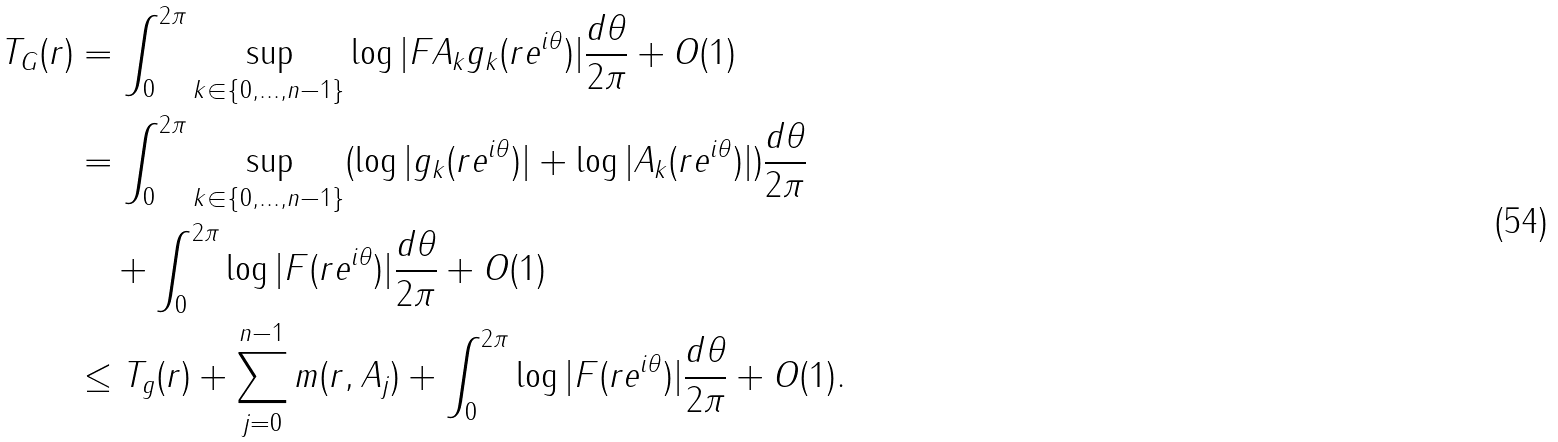Convert formula to latex. <formula><loc_0><loc_0><loc_500><loc_500>T _ { G } ( r ) & = \int _ { 0 } ^ { 2 \pi } \sup _ { k \in \{ 0 , \dots , n - 1 \} } \log | F A _ { k } g _ { k } ( r e ^ { i \theta } ) | \frac { d \theta } { 2 \pi } + O ( 1 ) \\ & = \int _ { 0 } ^ { 2 \pi } \sup _ { k \in \{ 0 , \dots , n - 1 \} } ( \log | g _ { k } ( r e ^ { i \theta } ) | + \log | A _ { k } ( r e ^ { i \theta } ) | ) \frac { d \theta } { 2 \pi } \\ & \quad + \int _ { 0 } ^ { 2 \pi } \log | F ( r e ^ { i \theta } ) | \frac { d \theta } { 2 \pi } + O ( 1 ) \\ & \leq T _ { g } ( r ) + \sum _ { j = 0 } ^ { n - 1 } m ( r , A _ { j } ) + \int _ { 0 } ^ { 2 \pi } \log | F ( r e ^ { i \theta } ) | \frac { d \theta } { 2 \pi } + O ( 1 ) . \\</formula> 